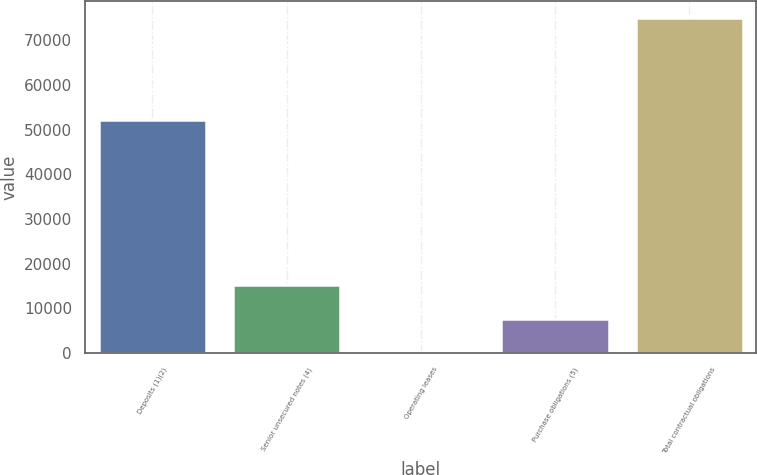Convert chart. <chart><loc_0><loc_0><loc_500><loc_500><bar_chart><fcel>Deposits (1)(2)<fcel>Senior unsecured notes (4)<fcel>Operating leases<fcel>Purchase obligations (5)<fcel>Total contractual obligations<nl><fcel>52121<fcel>15196.4<fcel>235<fcel>7715.7<fcel>75042<nl></chart> 